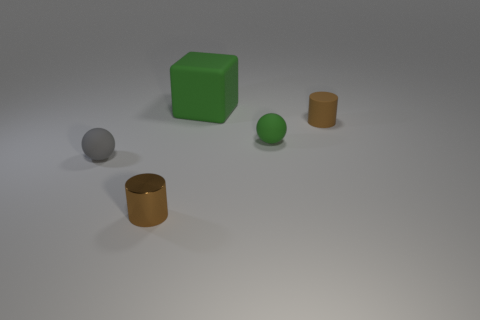Is the color of the tiny cylinder that is on the right side of the tiny metallic object the same as the tiny shiny cylinder? Yes, the small cylinder positioned to the right of the metallic object does indeed share the same color as the tiny shiny cylinder in the image, portraying uniformity in their color scheme. 